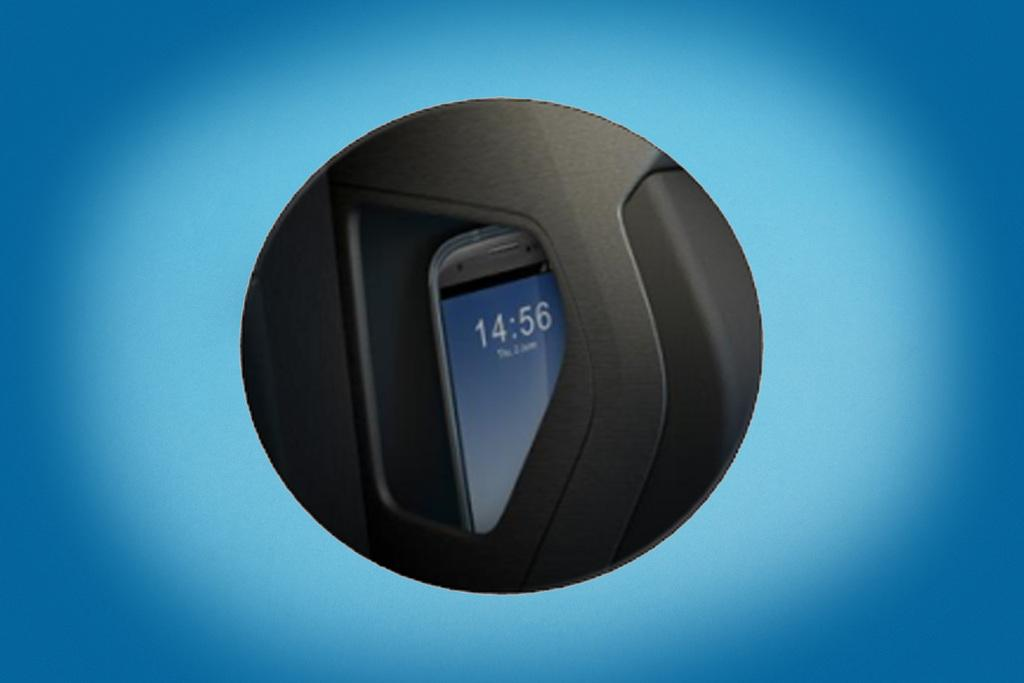<image>
Summarize the visual content of the image. a phone with the tie of 14:56 on it 